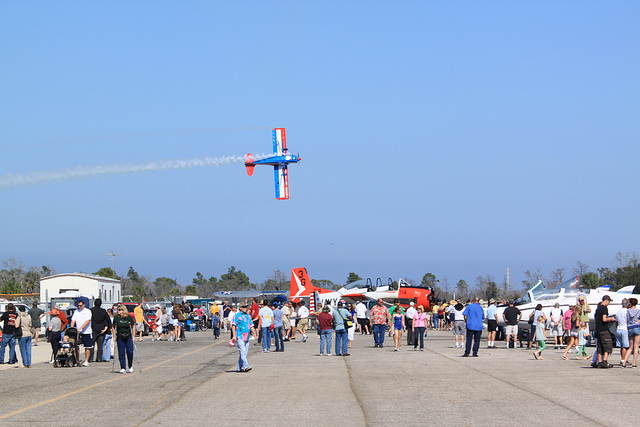Read all the text in this image. 3 